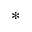Convert formula to latex. <formula><loc_0><loc_0><loc_500><loc_500>\ast</formula> 